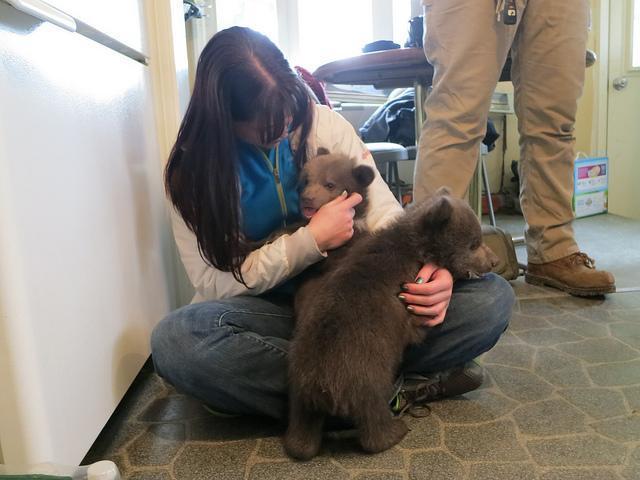How many dining tables are there?
Give a very brief answer. 1. How many bears are there?
Give a very brief answer. 2. How many people are there?
Give a very brief answer. 2. How many propellers does the airplane have?
Give a very brief answer. 0. 